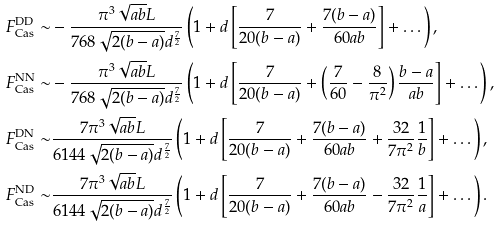Convert formula to latex. <formula><loc_0><loc_0><loc_500><loc_500>F _ { \text {Cas} } ^ { \text {DD} } \sim & - \frac { \pi ^ { 3 } \sqrt { a b } L } { 7 6 8 \sqrt { 2 ( b - a ) } d ^ { \frac { 7 } { 2 } } } \left ( 1 + d \left [ \frac { 7 } { 2 0 ( b - a ) } + \frac { 7 ( b - a ) } { 6 0 a b } \right ] + \dots \right ) , \\ F _ { \text {Cas} } ^ { \text {NN} } \sim & - \frac { \pi ^ { 3 } \sqrt { a b } L } { 7 6 8 \sqrt { 2 ( b - a ) } d ^ { \frac { 7 } { 2 } } } \left ( 1 + d \left [ \frac { 7 } { 2 0 ( b - a ) } + \left ( \frac { 7 } { 6 0 } - \frac { 8 } { \pi ^ { 2 } } \right ) \frac { b - a } { a b } \right ] + \dots \right ) , \\ F _ { \text {Cas} } ^ { \text {DN} } \sim & \frac { 7 \pi ^ { 3 } \sqrt { a b } L } { 6 1 4 4 \sqrt { 2 ( b - a ) } d ^ { \frac { 7 } { 2 } } } \left ( 1 + d \left [ \frac { 7 } { 2 0 ( b - a ) } + \frac { 7 ( b - a ) } { 6 0 a b } + \frac { 3 2 } { 7 \pi ^ { 2 } } \frac { 1 } { b } \right ] + \dots \right ) , \\ F _ { \text {Cas} } ^ { \text {ND} } \sim & \frac { 7 \pi ^ { 3 } \sqrt { a b } L } { 6 1 4 4 \sqrt { 2 ( b - a ) } d ^ { \frac { 7 } { 2 } } } \left ( 1 + d \left [ \frac { 7 } { 2 0 ( b - a ) } + \frac { 7 ( b - a ) } { 6 0 a b } - \frac { 3 2 } { 7 \pi ^ { 2 } } \frac { 1 } { a } \right ] + \dots \right ) .</formula> 